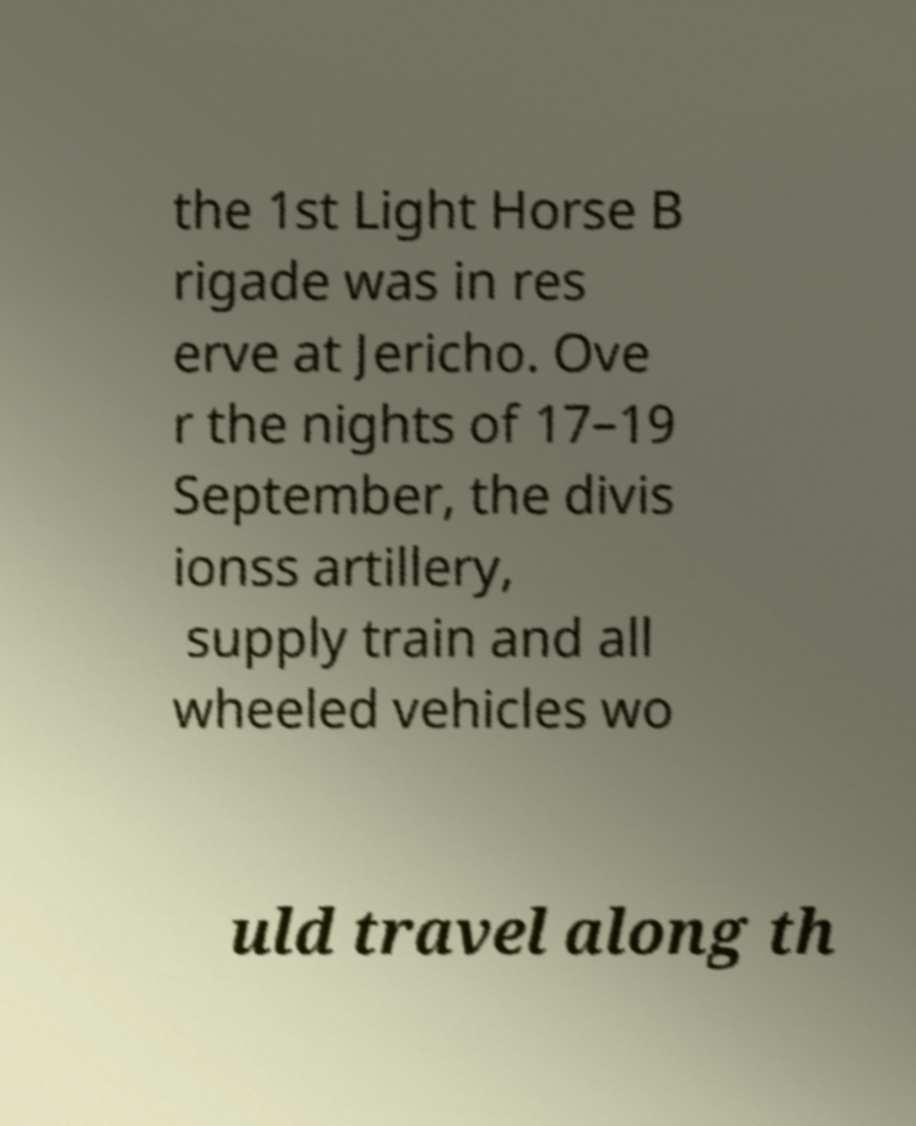For documentation purposes, I need the text within this image transcribed. Could you provide that? the 1st Light Horse B rigade was in res erve at Jericho. Ove r the nights of 17–19 September, the divis ionss artillery, supply train and all wheeled vehicles wo uld travel along th 